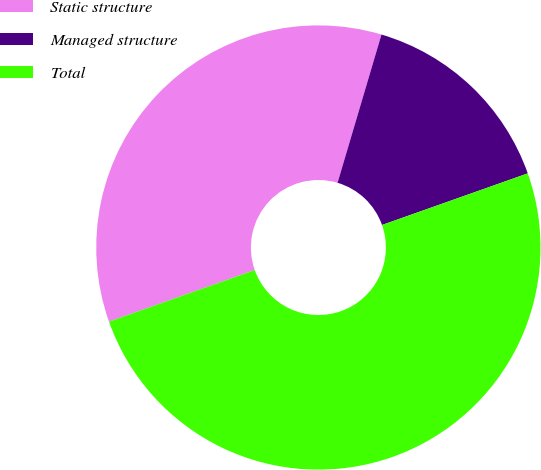<chart> <loc_0><loc_0><loc_500><loc_500><pie_chart><fcel>Static structure<fcel>Managed structure<fcel>Total<nl><fcel>35.0%<fcel>15.0%<fcel>50.0%<nl></chart> 